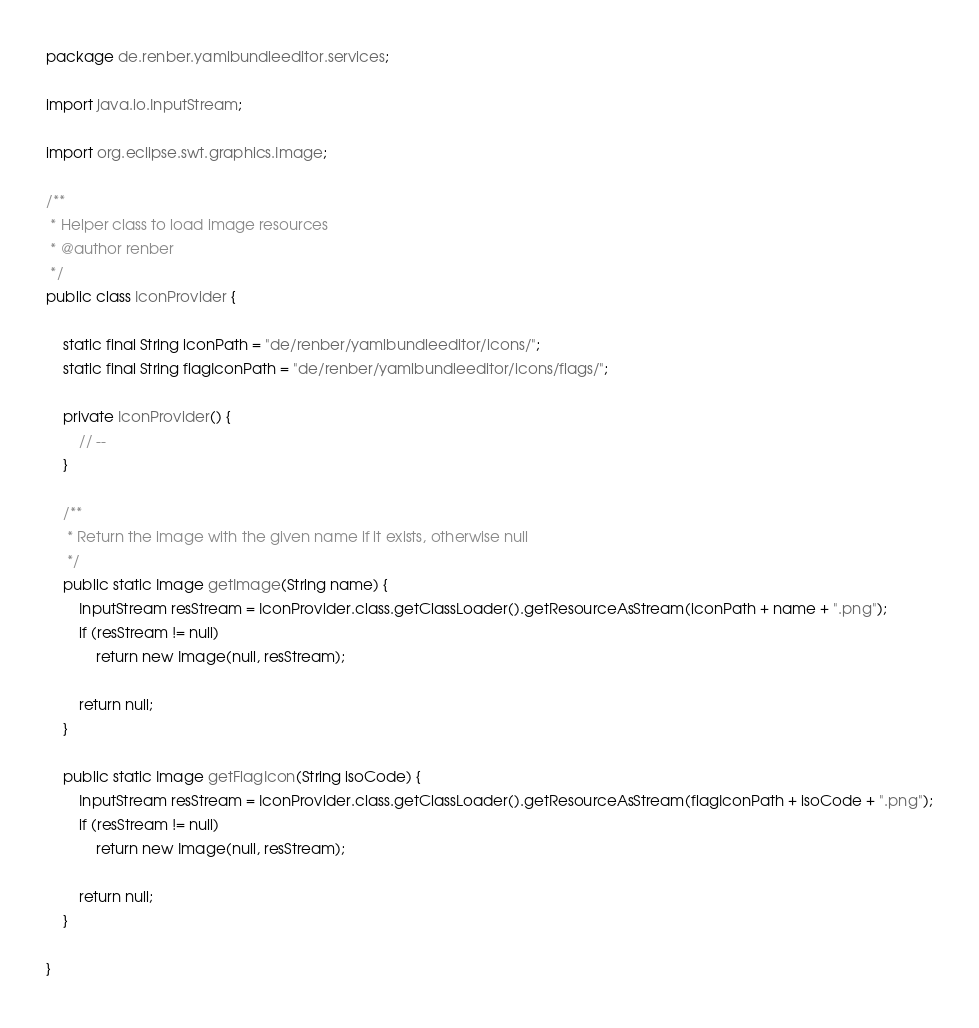<code> <loc_0><loc_0><loc_500><loc_500><_Java_>package de.renber.yamlbundleeditor.services;

import java.io.InputStream;

import org.eclipse.swt.graphics.Image;

/**
 * Helper class to load image resources
 * @author renber
 */
public class IconProvider {

	static final String iconPath = "de/renber/yamlbundleeditor/icons/";
	static final String flagIconPath = "de/renber/yamlbundleeditor/icons/flags/";
	
	private IconProvider() {
		// --
	}

	/**
	 * Return the image with the given name if it exists, otherwise null
	 */
	public static Image getImage(String name) {		
		InputStream resStream = IconProvider.class.getClassLoader().getResourceAsStream(iconPath + name + ".png");
		if (resStream != null)		
			return new Image(null, resStream);
					
		return null;		
	}
	
	public static Image getFlagIcon(String isoCode) {
		InputStream resStream = IconProvider.class.getClassLoader().getResourceAsStream(flagIconPath + isoCode + ".png");
		if (resStream != null)		
			return new Image(null, resStream);
					
		return null;		
	}
	
}
</code> 